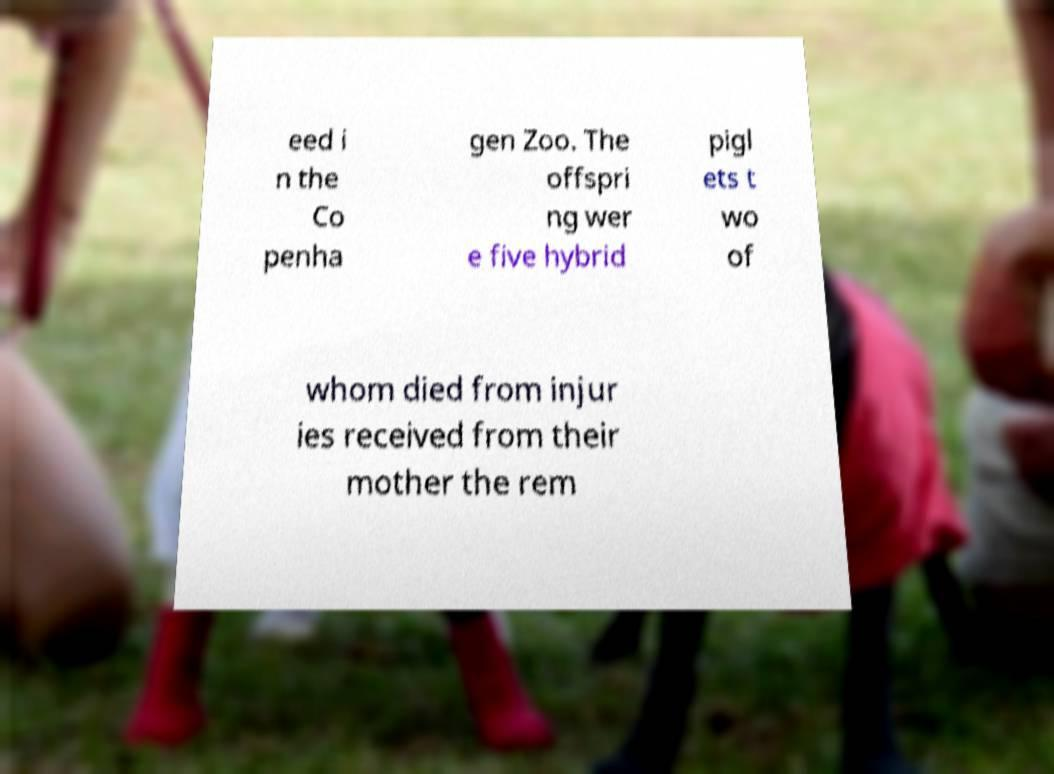Can you read and provide the text displayed in the image?This photo seems to have some interesting text. Can you extract and type it out for me? eed i n the Co penha gen Zoo. The offspri ng wer e five hybrid pigl ets t wo of whom died from injur ies received from their mother the rem 